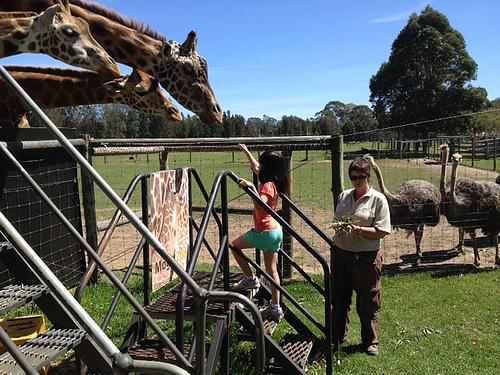Question: what color are the giraffes?
Choices:
A. Yellow and brown.
B. Orange.
C. Black and white.
D. Yellow.
Answer with the letter. Answer: A Question: where is this picture?
Choices:
A. The field.
B. The circus.
C. The carnival.
D. The zoo.
Answer with the letter. Answer: D 